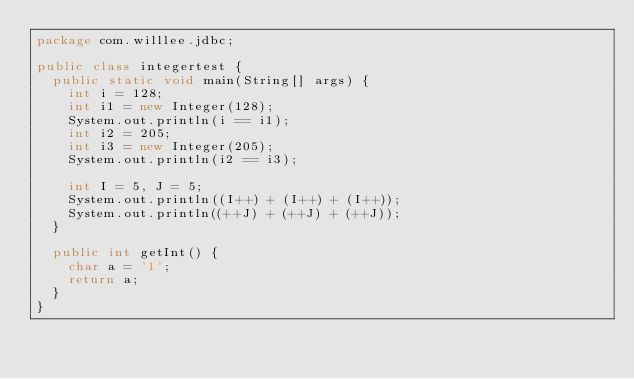<code> <loc_0><loc_0><loc_500><loc_500><_Java_>package com.willlee.jdbc;

public class integertest {
	public static void main(String[] args) {
		int i = 128;
		int i1 = new Integer(128);
		System.out.println(i == i1);
		int i2 = 205;
		int i3 = new Integer(205);
		System.out.println(i2 == i3);

		int I = 5, J = 5;
		System.out.println((I++) + (I++) + (I++));
		System.out.println((++J) + (++J) + (++J));
	}

	public int getInt() {
		char a = '1';
		return a;
	}
}
</code> 